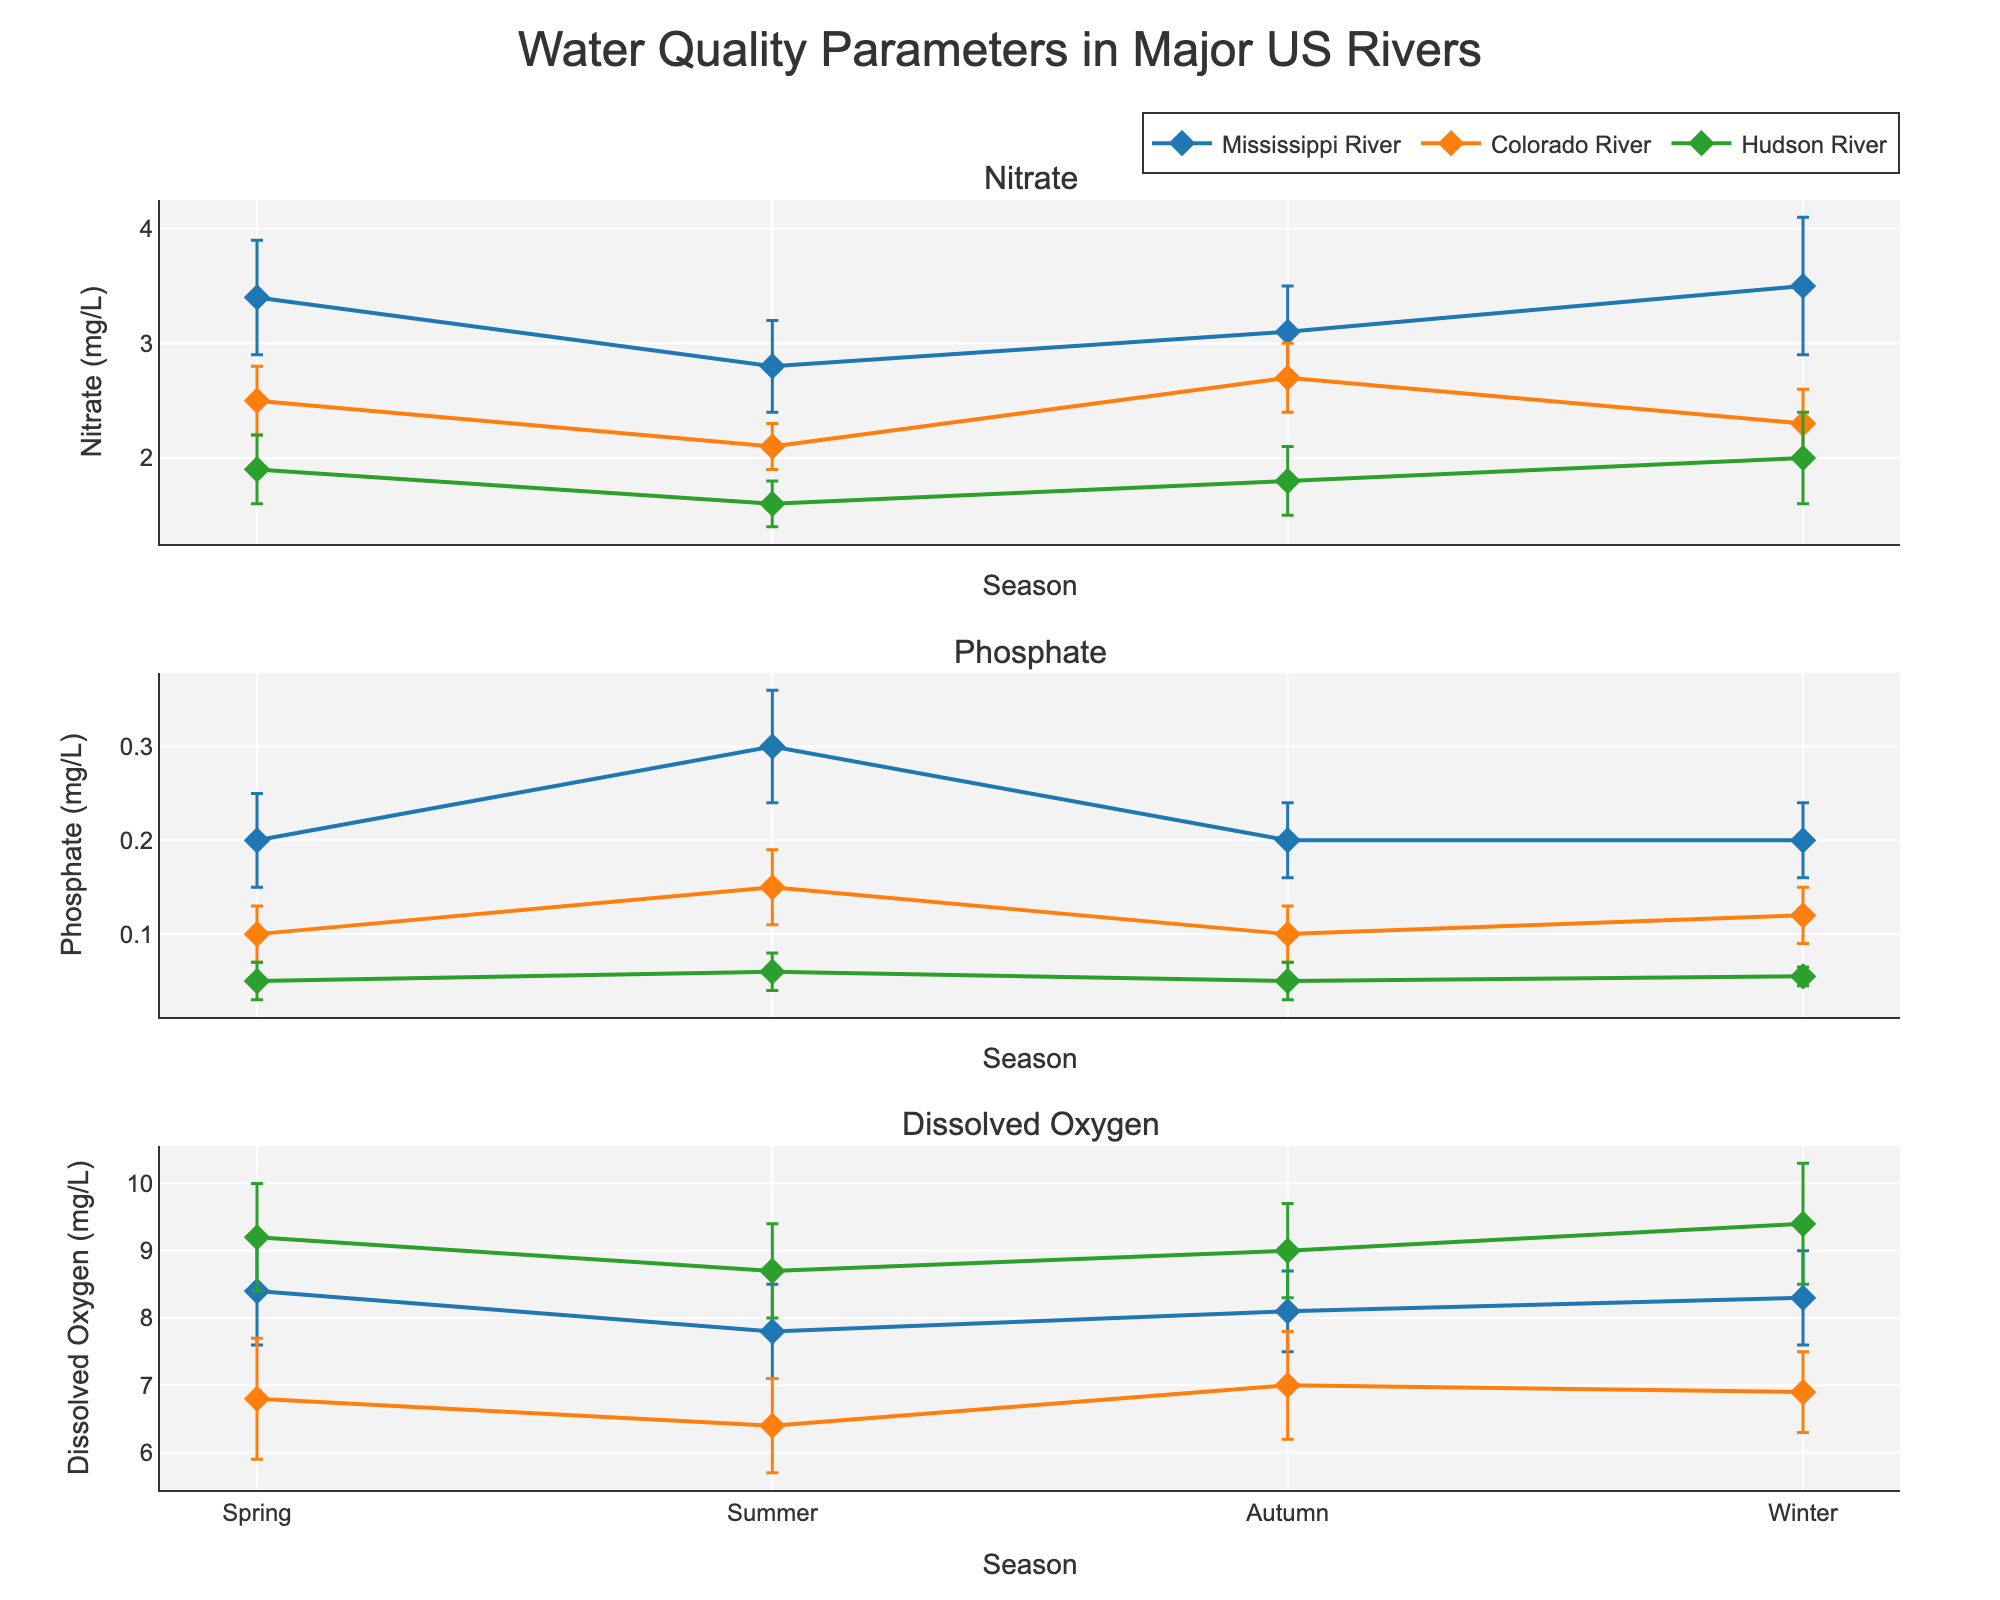What parameters are being measured in the figure? The subplot titles indicate that three parameters are being measured: Nitrate, Phosphate, and Dissolved Oxygen.
Answer: Nitrate, Phosphate, Dissolved Oxygen Which river shows the highest Nitrate levels in Spring? Look at the Nitrate plot's Spring data points. The Mississippi River’s Nitrate level is highest at 3.4 mg/L compared to other rivers.
Answer: Mississippi River How does the Phosphate level in the Hudson River change from Spring to Summer? Observe the Phosphate subplot for Hudson River between Spring and Summer. There is a slight increase from 0.05 mg/L to 0.06 mg/L.
Answer: It increases Does the Dissolved Oxygen level in the Colorado River in Winter exceed the level in Autumn? Compare the Dissolved Oxygen levels for Colorado River in Autumn (7.0 mg/L) and Winter (6.9 mg/L). The Winter level is slightly lower.
Answer: No Which season shows the highest average Dissolved Oxygen level for the Mississippi River? Check the Dissolved Oxygen subplot for Mississippi River across the seasons. The highest level appears in Spring with an average of 8.4 mg/L.
Answer: Spring What is the difference in Nitrate levels between Summer and Winter in the Colorado River? Compare Nitrate levels in Summer (2.1 mg/L) and Winter (2.3 mg/L), and calculate the difference: 2.3 - 2.1 = 0.2 mg/L.
Answer: 0.2 mg/L Are the standard deviation error bars for Phosphate generally larger or smaller than those for Nitrate? By examining all subplots, Phosphate error bars (around 0.03-0.06 mg/L) are generally smaller than those for Nitrate (around 0.2-0.6 mg/L).
Answer: Smaller What is the general trend of Dissolved Oxygen levels in the Mississippi River from Spring to Winter? Track the Dissolved Oxygen levels in the Mississippi River subplots from Spring (8.4 mg/L) to Winter (8.3 mg/L). There is a slight decrease and stabilization after Spring.
Answer: Slight decrease/stabilize Which river has the lowest variability in Phosphate levels during Autumn? Look at the Phosphate subplot for Autumn. The Hudson River has the smallest standard deviation with 0.02 mg/L.
Answer: Hudson River 